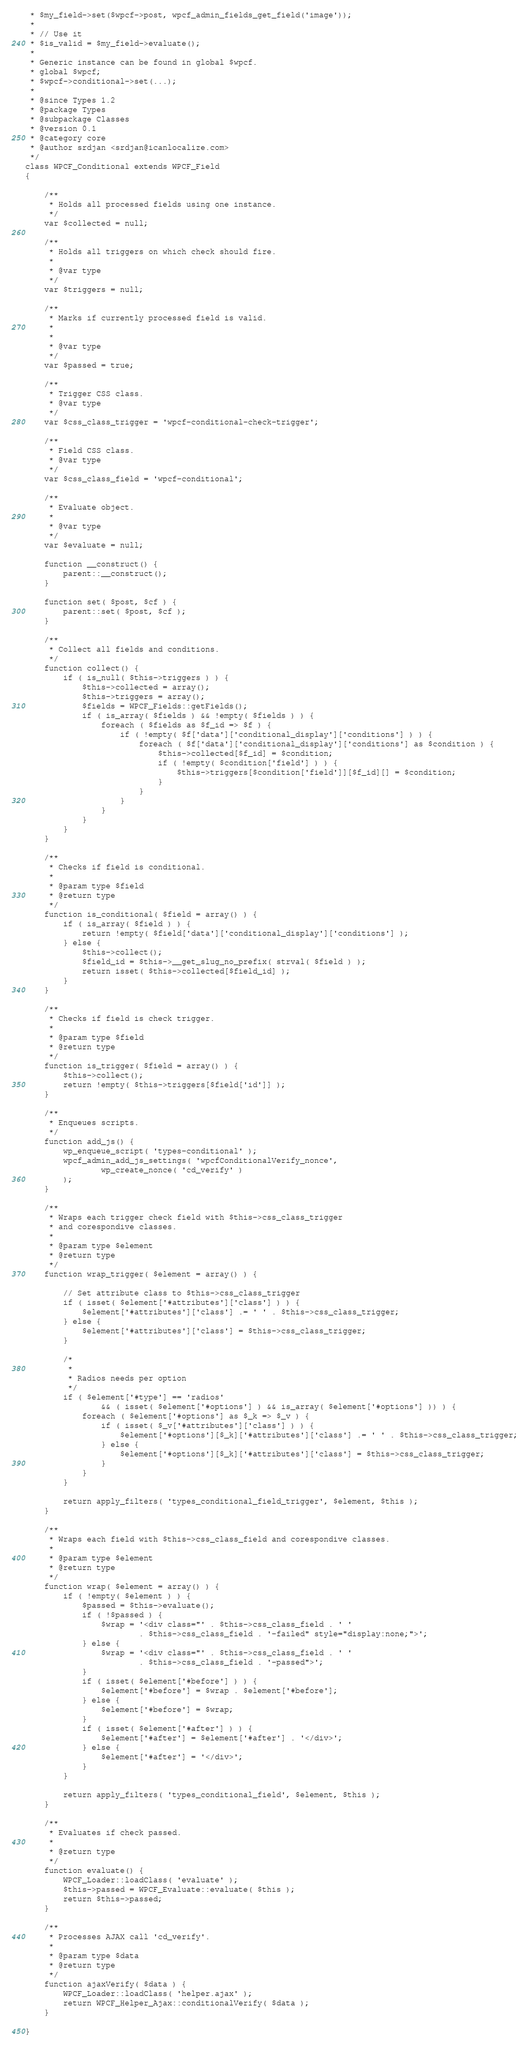<code> <loc_0><loc_0><loc_500><loc_500><_PHP_> * $my_field->set($wpcf->post, wpcf_admin_fields_get_field('image'));
 * 
 * // Use it
 * $is_valid = $my_field->evaluate();
 * 
 * Generic instance can be found in global $wpcf.
 * global $wpcf;
 * $wpcf->conditional->set(...);
 * 
 * @since Types 1.2
 * @package Types
 * @subpackage Classes
 * @version 0.1
 * @category core
 * @author srdjan <srdjan@icanlocalize.com>
 */
class WPCF_Conditional extends WPCF_Field
{

    /**
     * Holds all processed fields using one instance.
     */
    var $collected = null;

    /**
     * Holds all triggers on which check should fire.
     * 
     * @var type 
     */
    var $triggers = null;

    /**
     * Marks if currently processed field is valid.
     * 
     * 
     * @var type 
     */
    var $passed = true;

    /**
     * Trigger CSS class.
     * @var type 
     */
    var $css_class_trigger = 'wpcf-conditional-check-trigger';

    /**
     * Field CSS class.
     * @var type 
     */
    var $css_class_field = 'wpcf-conditional';

    /**
     * Evaluate object.
     * 
     * @var type 
     */
    var $evaluate = null;

    function __construct() {
        parent::__construct();
    }

    function set( $post, $cf ) {
        parent::set( $post, $cf );
    }

    /**
     * Collect all fields and conditions.
     */
    function collect() {
        if ( is_null( $this->triggers ) ) {
            $this->collected = array();
            $this->triggers = array();
            $fields = WPCF_Fields::getFields();
            if ( is_array( $fields ) && !empty( $fields ) ) {
                foreach ( $fields as $f_id => $f ) {
                    if ( !empty( $f['data']['conditional_display']['conditions'] ) ) {
                        foreach ( $f['data']['conditional_display']['conditions'] as $condition ) {
                            $this->collected[$f_id] = $condition;
                            if ( !empty( $condition['field'] ) ) {
                                $this->triggers[$condition['field']][$f_id][] = $condition;
                            }
                        }
                    }
                }
            }
        }
    }

    /**
     * Checks if field is conditional.
     * 
     * @param type $field
     * @return type 
     */
    function is_conditional( $field = array() ) {
        if ( is_array( $field ) ) {
            return !empty( $field['data']['conditional_display']['conditions'] );
        } else {
            $this->collect();
            $field_id = $this->__get_slug_no_prefix( strval( $field ) );
            return isset( $this->collected[$field_id] );
        }
    }

    /**
     * Checks if field is check trigger.
     * 
     * @param type $field
     * @return type 
     */
    function is_trigger( $field = array() ) {
        $this->collect();
        return !empty( $this->triggers[$field['id']] );
    }

    /**
     * Enqueues scripts. 
     */
    function add_js() {
        wp_enqueue_script( 'types-conditional' );
        wpcf_admin_add_js_settings( 'wpcfConditionalVerify_nonce',
                wp_create_nonce( 'cd_verify' )
        );
    }

    /**
     * Wraps each trigger check field with $this->css_class_trigger
     * and corespondive classes.
     * 
     * @param type $element
     * @return type 
     */
    function wrap_trigger( $element = array() ) {

        // Set attribute class to $this->css_class_trigger
        if ( isset( $element['#attributes']['class'] ) ) {
            $element['#attributes']['class'] .= ' ' . $this->css_class_trigger;
        } else {
            $element['#attributes']['class'] = $this->css_class_trigger;
        }

        /*
         * 
         * Radios needs per option
         */
        if ( $element['#type'] == 'radios'
                && ( isset( $element['#options'] ) && is_array( $element['#options'] )) ) {
            foreach ( $element['#options'] as $_k => $_v ) {
                if ( isset( $_v['#attributes']['class'] ) ) {
                    $element['#options'][$_k]['#attributes']['class'] .= ' ' . $this->css_class_trigger;
                } else {
                    $element['#options'][$_k]['#attributes']['class'] = $this->css_class_trigger;
                }
            }
        }

        return apply_filters( 'types_conditional_field_trigger', $element, $this );
    }

    /**
     * Wraps each field with $this->css_class_field and corespondive classes.
     * 
     * @param type $element
     * @return type 
     */
    function wrap( $element = array() ) {
        if ( !empty( $element ) ) {
            $passed = $this->evaluate();
            if ( !$passed ) {
                $wrap = '<div class="' . $this->css_class_field . ' '
                        . $this->css_class_field . '-failed" style="display:none;">';
            } else {
                $wrap = '<div class="' . $this->css_class_field . ' '
                        . $this->css_class_field . '-passed">';
            }
            if ( isset( $element['#before'] ) ) {
                $element['#before'] = $wrap . $element['#before'];
            } else {
                $element['#before'] = $wrap;
            }
            if ( isset( $element['#after'] ) ) {
                $element['#after'] = $element['#after'] . '</div>';
            } else {
                $element['#after'] = '</div>';
            }
        }

        return apply_filters( 'types_conditional_field', $element, $this );
    }

    /**
     * Evaluates if check passed.
     * 
     * @return type 
     */
    function evaluate() {
        WPCF_Loader::loadClass( 'evaluate' );
        $this->passed = WPCF_Evaluate::evaluate( $this );
        return $this->passed;
    }

    /**
     * Processes AJAX call 'cd_verify'.
     * 
     * @param type $data
     * @return type
     */
    function ajaxVerify( $data ) {
        WPCF_Loader::loadClass( 'helper.ajax' );
        return WPCF_Helper_Ajax::conditionalVerify( $data );
    }

}</code> 